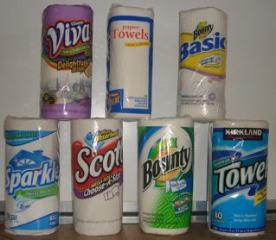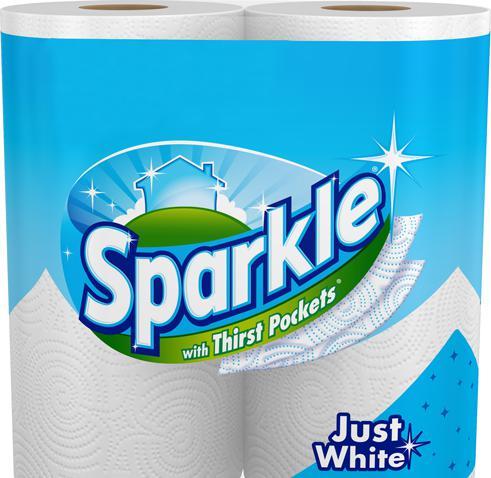The first image is the image on the left, the second image is the image on the right. Evaluate the accuracy of this statement regarding the images: "There are exactly two rolls of paper towels.". Is it true? Answer yes or no. No. The first image is the image on the left, the second image is the image on the right. For the images displayed, is the sentence "Each image shows a single upright roll of paper towels, and the left and right rolls do not have identical packaging." factually correct? Answer yes or no. No. 